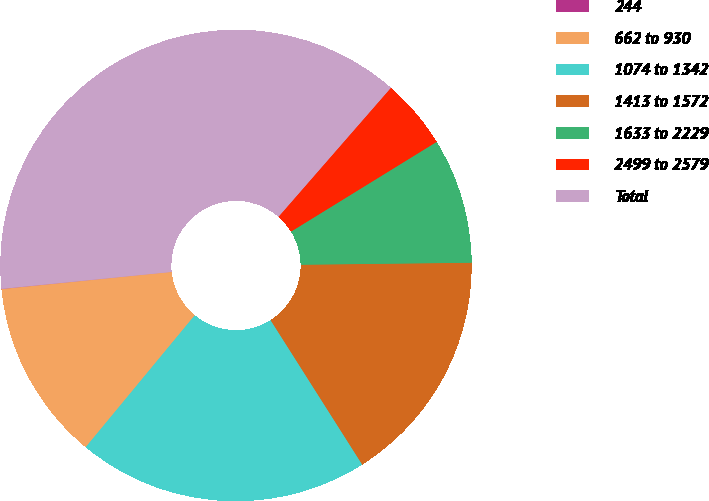Convert chart. <chart><loc_0><loc_0><loc_500><loc_500><pie_chart><fcel>244<fcel>662 to 930<fcel>1074 to 1342<fcel>1413 to 1572<fcel>1633 to 2229<fcel>2499 to 2579<fcel>Total<nl><fcel>0.02%<fcel>12.4%<fcel>19.99%<fcel>16.19%<fcel>8.6%<fcel>4.8%<fcel>37.99%<nl></chart> 